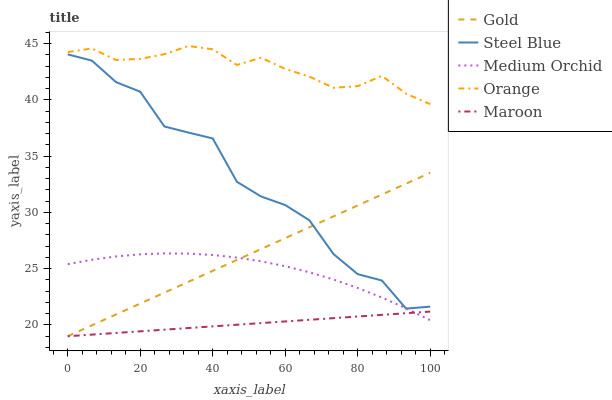Does Maroon have the minimum area under the curve?
Answer yes or no. Yes. Does Orange have the maximum area under the curve?
Answer yes or no. Yes. Does Medium Orchid have the minimum area under the curve?
Answer yes or no. No. Does Medium Orchid have the maximum area under the curve?
Answer yes or no. No. Is Gold the smoothest?
Answer yes or no. Yes. Is Steel Blue the roughest?
Answer yes or no. Yes. Is Maroon the smoothest?
Answer yes or no. No. Is Maroon the roughest?
Answer yes or no. No. Does Maroon have the lowest value?
Answer yes or no. Yes. Does Medium Orchid have the lowest value?
Answer yes or no. No. Does Orange have the highest value?
Answer yes or no. Yes. Does Medium Orchid have the highest value?
Answer yes or no. No. Is Medium Orchid less than Orange?
Answer yes or no. Yes. Is Orange greater than Gold?
Answer yes or no. Yes. Does Medium Orchid intersect Gold?
Answer yes or no. Yes. Is Medium Orchid less than Gold?
Answer yes or no. No. Is Medium Orchid greater than Gold?
Answer yes or no. No. Does Medium Orchid intersect Orange?
Answer yes or no. No. 